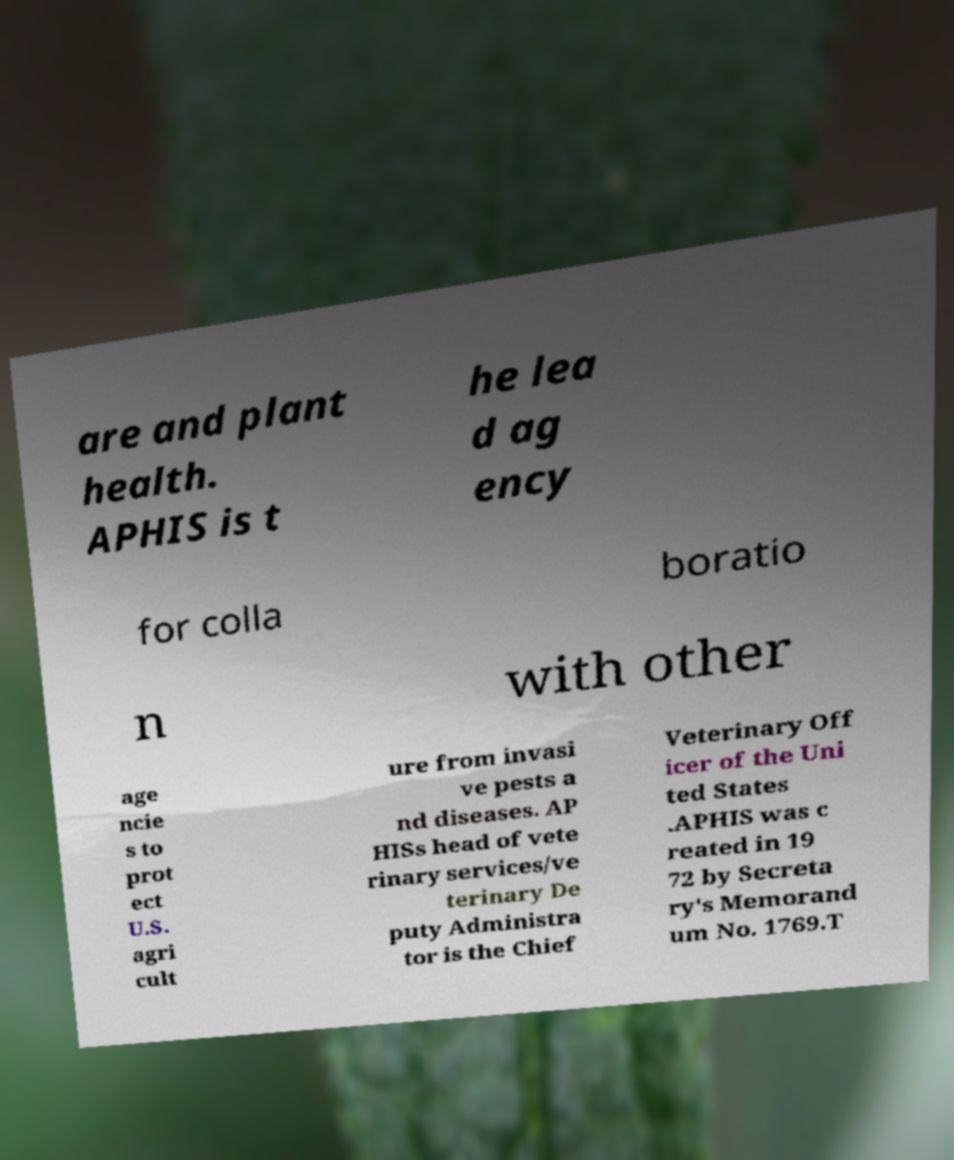Please identify and transcribe the text found in this image. are and plant health. APHIS is t he lea d ag ency for colla boratio n with other age ncie s to prot ect U.S. agri cult ure from invasi ve pests a nd diseases. AP HISs head of vete rinary services/ve terinary De puty Administra tor is the Chief Veterinary Off icer of the Uni ted States .APHIS was c reated in 19 72 by Secreta ry's Memorand um No. 1769.T 